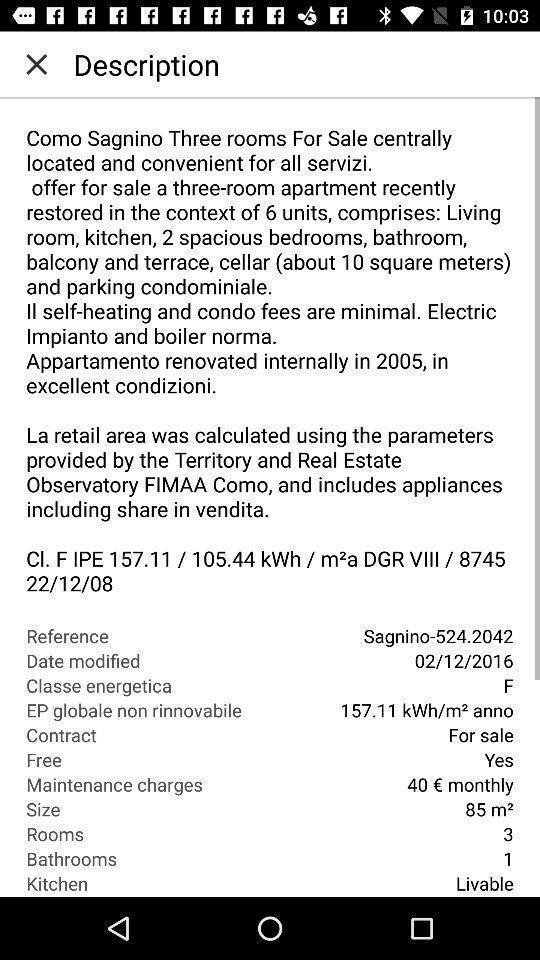Give me a summary of this screen capture. Page showing information about description. 